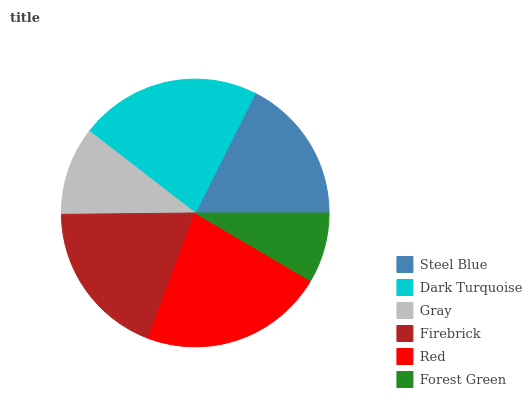Is Forest Green the minimum?
Answer yes or no. Yes. Is Red the maximum?
Answer yes or no. Yes. Is Dark Turquoise the minimum?
Answer yes or no. No. Is Dark Turquoise the maximum?
Answer yes or no. No. Is Dark Turquoise greater than Steel Blue?
Answer yes or no. Yes. Is Steel Blue less than Dark Turquoise?
Answer yes or no. Yes. Is Steel Blue greater than Dark Turquoise?
Answer yes or no. No. Is Dark Turquoise less than Steel Blue?
Answer yes or no. No. Is Firebrick the high median?
Answer yes or no. Yes. Is Steel Blue the low median?
Answer yes or no. Yes. Is Dark Turquoise the high median?
Answer yes or no. No. Is Red the low median?
Answer yes or no. No. 